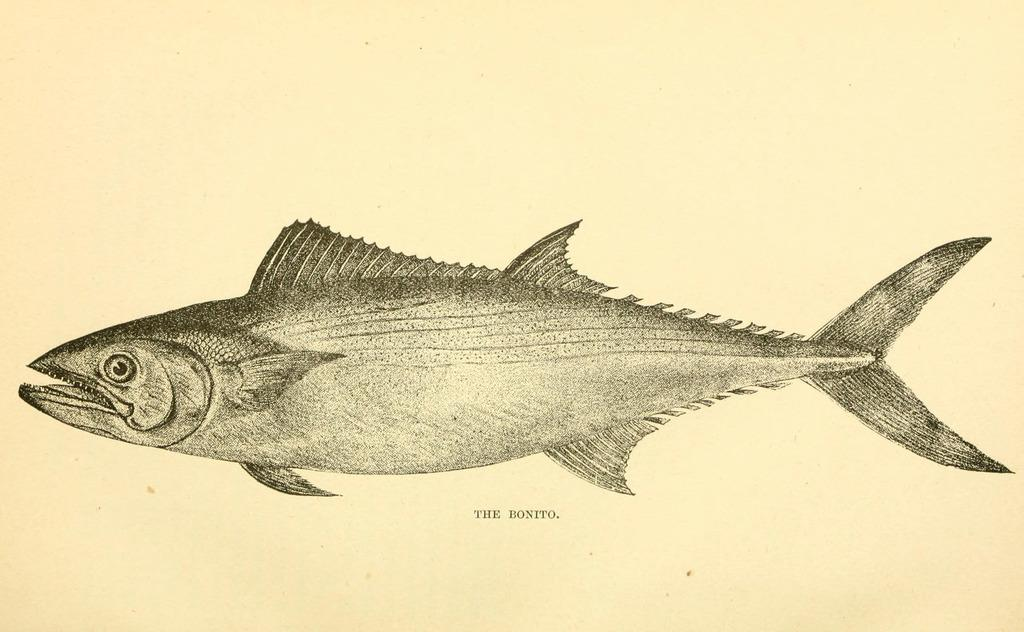What type of animal is in the image? There is a fish in the image. Is there any text associated with the fish in the image? Yes, there is a name below the fish in the image. What type of stew is being prepared in the image? There is no stew present in the image; it features a fish with a name below it. What kind of noise can be heard coming from the fish in the image? Fish do not make noise, so there is no noise coming from the fish in the image. 